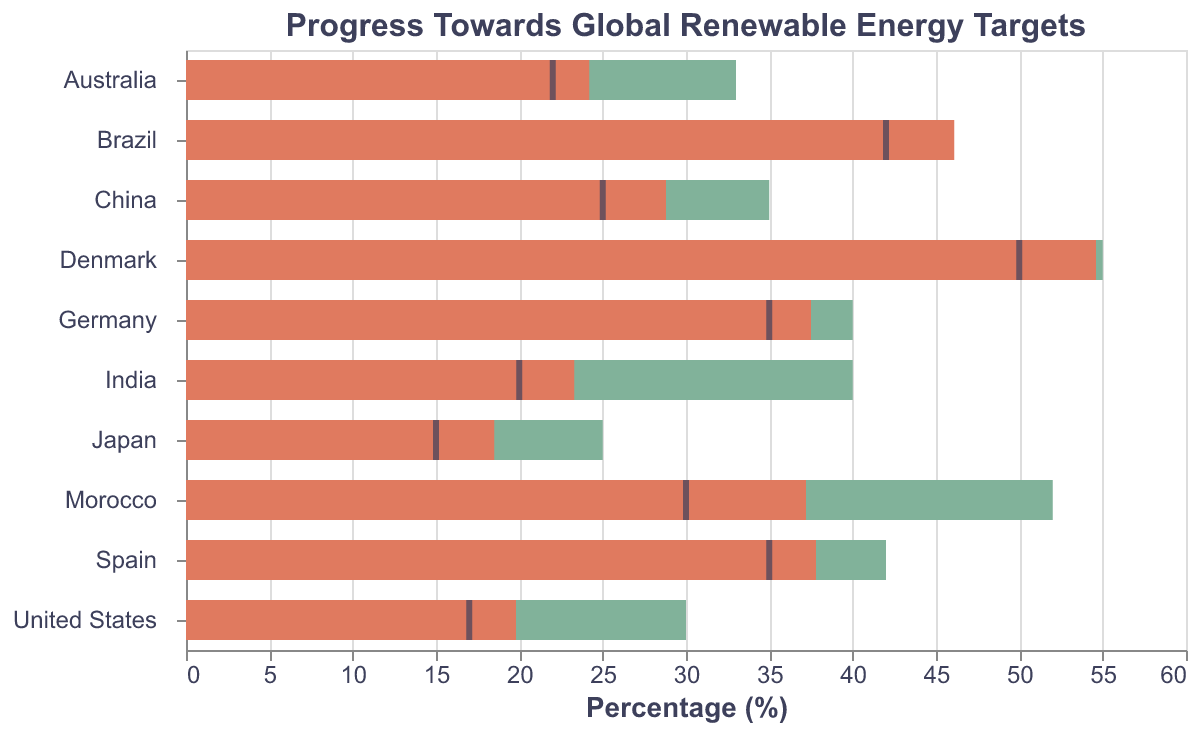What is the title of the figure? The title of the figure is displayed at the top and specifies the context of the data visualization.
Answer: Progress Towards Global Renewable Energy Targets Which country has the highest renewable energy target percentage? By examining the horizontal bars representing the targets, we can identify the country with the longest bar.
Answer: Denmark Which country exceeded its renewable energy target? By comparing the Actual and Target bars for each country, we notice which country's Actual value exceeds its Target value.
Answer: Brazil How much is Germany short of its renewable energy target in percentage? Subtract Germany's Actual value from its Target value (Target - Actual). This gives us 40 - 37.5 = 2.5.
Answer: 2.5% What is Denmark's distance from its comparative value? Subtract Denmark's Comparative value from its Actual value (Actual - Comparative). This gives us 54.6 - 50 = 4.6.
Answer: 4.6% Which countries have actual renewable energy percentages below 20%? By observing the Actual bars and identifying those below the 20% mark, we find Japan (18.5%) and the United States (19.8%).
Answer: Japan, United States Compare the renewable energy targets of China and India. Which country has a higher target and by how much? Subtract China's Target value from India's Target value to find the difference (India - China). This gives us 40 - 35 = 5. India has a higher target by 5%.
Answer: India, by 5% What is the average of the actual renewable energy percentages for all the countries? Sum the Actual values for all countries and divide by the number of countries: (37.5 + 28.8 + 19.8 + 46.1 + 23.3 + 54.6 + 18.5 + 24.2 + 37.8 + 37.2) / 10 = 32.78.
Answer: 32.78% Which country is closest to achieving its target without exceeding it? Find the country with the smallest difference between its Target and Actual values without exceeding the Actual value. For this, Germany has 40 - 37.5 = 2.5. Next, China 35 - 28.8 = 6.2, United States 30 - 19.8 = 10.2, and so on. 2.5 is the smallest positive difference.
Answer: Germany 